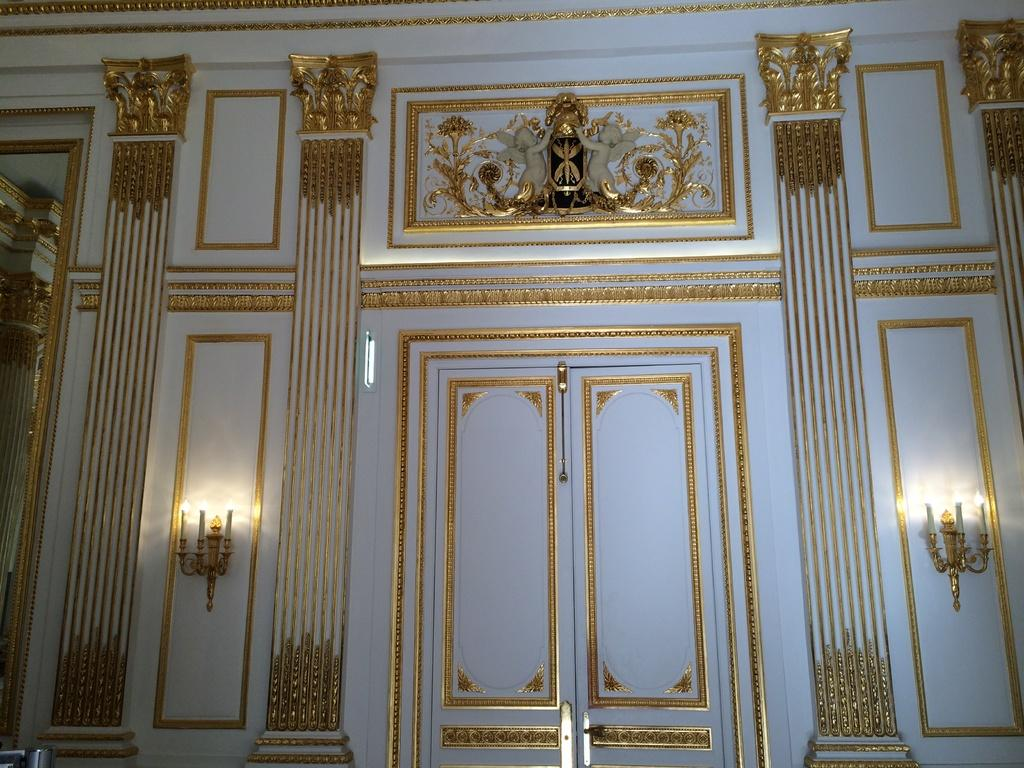What is located in the center of the image? There are two doors in the center of the image. How many candles are present on each side of the doors? There are six candles on each side of the doors. What can be seen on the top side of the image? There are sculptures visible on the top side of the image. What book is being read by the sculpture on the top side of the image? There is no book present in the image, and the sculptures are not depicted as reading. What songs are being sung by the candles on each side of the doors? The candles are not depicted as singing, and there is no mention of songs in the image. 